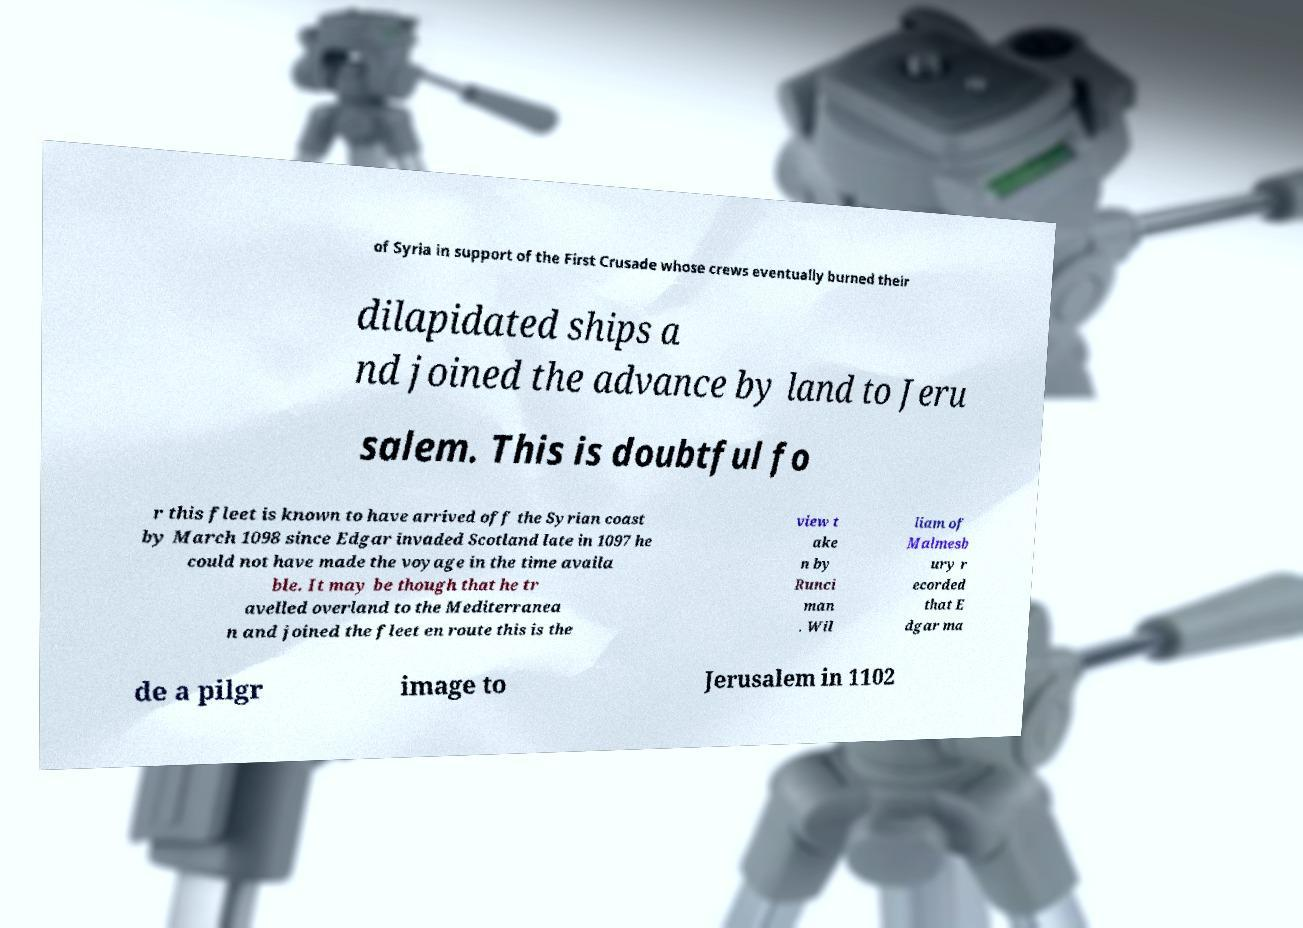Could you assist in decoding the text presented in this image and type it out clearly? of Syria in support of the First Crusade whose crews eventually burned their dilapidated ships a nd joined the advance by land to Jeru salem. This is doubtful fo r this fleet is known to have arrived off the Syrian coast by March 1098 since Edgar invaded Scotland late in 1097 he could not have made the voyage in the time availa ble. It may be though that he tr avelled overland to the Mediterranea n and joined the fleet en route this is the view t ake n by Runci man . Wil liam of Malmesb ury r ecorded that E dgar ma de a pilgr image to Jerusalem in 1102 